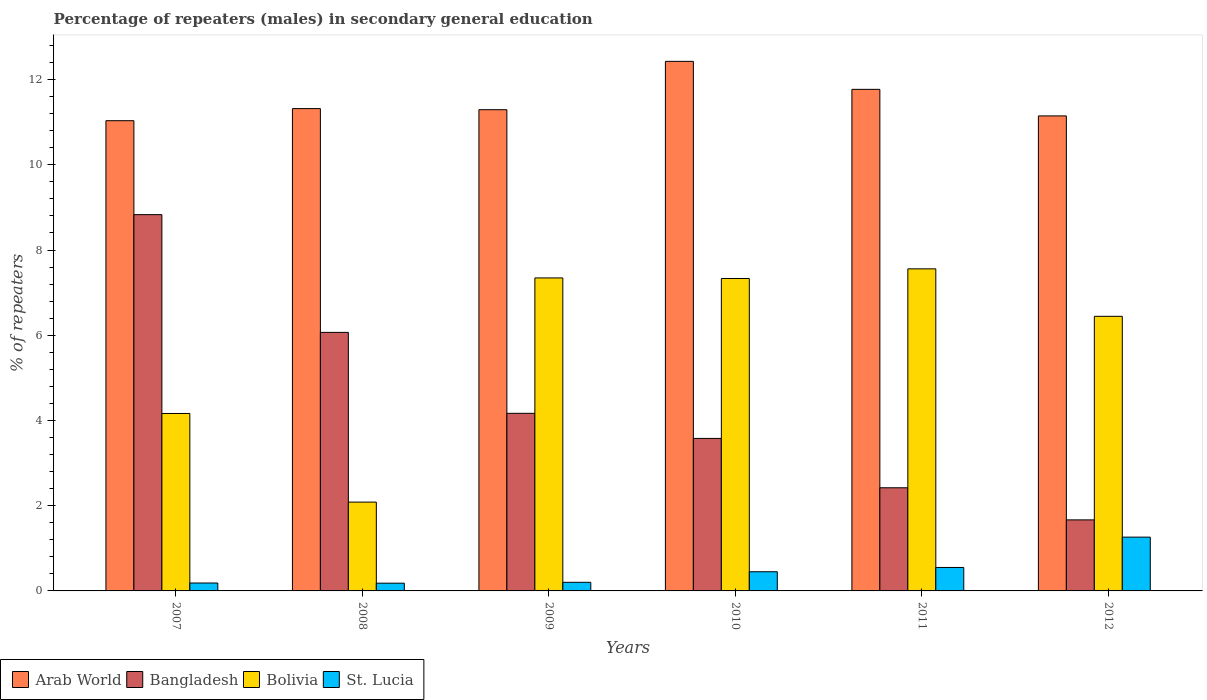How many different coloured bars are there?
Give a very brief answer. 4. How many groups of bars are there?
Your response must be concise. 6. Are the number of bars per tick equal to the number of legend labels?
Make the answer very short. Yes. Are the number of bars on each tick of the X-axis equal?
Offer a very short reply. Yes. What is the label of the 3rd group of bars from the left?
Make the answer very short. 2009. What is the percentage of male repeaters in St. Lucia in 2008?
Provide a succinct answer. 0.18. Across all years, what is the maximum percentage of male repeaters in Arab World?
Your answer should be very brief. 12.43. Across all years, what is the minimum percentage of male repeaters in Arab World?
Your response must be concise. 11.03. In which year was the percentage of male repeaters in St. Lucia maximum?
Offer a terse response. 2012. What is the total percentage of male repeaters in Arab World in the graph?
Your answer should be compact. 68.99. What is the difference between the percentage of male repeaters in Arab World in 2007 and that in 2008?
Provide a short and direct response. -0.28. What is the difference between the percentage of male repeaters in Bangladesh in 2008 and the percentage of male repeaters in Bolivia in 2012?
Offer a terse response. -0.38. What is the average percentage of male repeaters in St. Lucia per year?
Your answer should be very brief. 0.47. In the year 2008, what is the difference between the percentage of male repeaters in St. Lucia and percentage of male repeaters in Bangladesh?
Give a very brief answer. -5.89. In how many years, is the percentage of male repeaters in Arab World greater than 4.4 %?
Your response must be concise. 6. What is the ratio of the percentage of male repeaters in Arab World in 2008 to that in 2012?
Your answer should be very brief. 1.02. What is the difference between the highest and the second highest percentage of male repeaters in Bangladesh?
Give a very brief answer. 2.76. What is the difference between the highest and the lowest percentage of male repeaters in Arab World?
Offer a very short reply. 1.39. In how many years, is the percentage of male repeaters in Arab World greater than the average percentage of male repeaters in Arab World taken over all years?
Your response must be concise. 2. Are all the bars in the graph horizontal?
Your answer should be very brief. No. Are the values on the major ticks of Y-axis written in scientific E-notation?
Provide a succinct answer. No. Does the graph contain any zero values?
Offer a terse response. No. Does the graph contain grids?
Your answer should be compact. No. How are the legend labels stacked?
Offer a very short reply. Horizontal. What is the title of the graph?
Keep it short and to the point. Percentage of repeaters (males) in secondary general education. Does "European Union" appear as one of the legend labels in the graph?
Make the answer very short. No. What is the label or title of the Y-axis?
Your response must be concise. % of repeaters. What is the % of repeaters of Arab World in 2007?
Keep it short and to the point. 11.03. What is the % of repeaters in Bangladesh in 2007?
Keep it short and to the point. 8.83. What is the % of repeaters in Bolivia in 2007?
Keep it short and to the point. 4.16. What is the % of repeaters of St. Lucia in 2007?
Give a very brief answer. 0.19. What is the % of repeaters of Arab World in 2008?
Offer a very short reply. 11.32. What is the % of repeaters of Bangladesh in 2008?
Give a very brief answer. 6.07. What is the % of repeaters in Bolivia in 2008?
Provide a short and direct response. 2.08. What is the % of repeaters of St. Lucia in 2008?
Provide a succinct answer. 0.18. What is the % of repeaters in Arab World in 2009?
Make the answer very short. 11.29. What is the % of repeaters in Bangladesh in 2009?
Offer a very short reply. 4.17. What is the % of repeaters in Bolivia in 2009?
Provide a short and direct response. 7.34. What is the % of repeaters in St. Lucia in 2009?
Keep it short and to the point. 0.2. What is the % of repeaters of Arab World in 2010?
Your answer should be very brief. 12.43. What is the % of repeaters in Bangladesh in 2010?
Your answer should be compact. 3.58. What is the % of repeaters of Bolivia in 2010?
Your answer should be very brief. 7.33. What is the % of repeaters of St. Lucia in 2010?
Give a very brief answer. 0.45. What is the % of repeaters in Arab World in 2011?
Make the answer very short. 11.77. What is the % of repeaters of Bangladesh in 2011?
Your answer should be compact. 2.42. What is the % of repeaters of Bolivia in 2011?
Provide a succinct answer. 7.56. What is the % of repeaters in St. Lucia in 2011?
Your response must be concise. 0.55. What is the % of repeaters of Arab World in 2012?
Ensure brevity in your answer.  11.15. What is the % of repeaters in Bangladesh in 2012?
Keep it short and to the point. 1.67. What is the % of repeaters in Bolivia in 2012?
Your answer should be compact. 6.44. What is the % of repeaters of St. Lucia in 2012?
Your answer should be compact. 1.26. Across all years, what is the maximum % of repeaters of Arab World?
Offer a terse response. 12.43. Across all years, what is the maximum % of repeaters of Bangladesh?
Provide a short and direct response. 8.83. Across all years, what is the maximum % of repeaters of Bolivia?
Offer a terse response. 7.56. Across all years, what is the maximum % of repeaters in St. Lucia?
Offer a terse response. 1.26. Across all years, what is the minimum % of repeaters of Arab World?
Your response must be concise. 11.03. Across all years, what is the minimum % of repeaters in Bangladesh?
Your answer should be compact. 1.67. Across all years, what is the minimum % of repeaters in Bolivia?
Provide a short and direct response. 2.08. Across all years, what is the minimum % of repeaters in St. Lucia?
Provide a succinct answer. 0.18. What is the total % of repeaters in Arab World in the graph?
Provide a succinct answer. 68.99. What is the total % of repeaters of Bangladesh in the graph?
Provide a succinct answer. 26.73. What is the total % of repeaters in Bolivia in the graph?
Your response must be concise. 34.93. What is the total % of repeaters of St. Lucia in the graph?
Keep it short and to the point. 2.83. What is the difference between the % of repeaters of Arab World in 2007 and that in 2008?
Provide a short and direct response. -0.28. What is the difference between the % of repeaters of Bangladesh in 2007 and that in 2008?
Your response must be concise. 2.76. What is the difference between the % of repeaters of Bolivia in 2007 and that in 2008?
Offer a very short reply. 2.08. What is the difference between the % of repeaters of St. Lucia in 2007 and that in 2008?
Your answer should be very brief. 0. What is the difference between the % of repeaters in Arab World in 2007 and that in 2009?
Offer a very short reply. -0.26. What is the difference between the % of repeaters in Bangladesh in 2007 and that in 2009?
Provide a short and direct response. 4.66. What is the difference between the % of repeaters in Bolivia in 2007 and that in 2009?
Keep it short and to the point. -3.18. What is the difference between the % of repeaters in St. Lucia in 2007 and that in 2009?
Offer a very short reply. -0.02. What is the difference between the % of repeaters in Arab World in 2007 and that in 2010?
Your answer should be very brief. -1.39. What is the difference between the % of repeaters of Bangladesh in 2007 and that in 2010?
Provide a short and direct response. 5.25. What is the difference between the % of repeaters in Bolivia in 2007 and that in 2010?
Offer a very short reply. -3.17. What is the difference between the % of repeaters of St. Lucia in 2007 and that in 2010?
Give a very brief answer. -0.26. What is the difference between the % of repeaters in Arab World in 2007 and that in 2011?
Offer a very short reply. -0.74. What is the difference between the % of repeaters of Bangladesh in 2007 and that in 2011?
Provide a short and direct response. 6.41. What is the difference between the % of repeaters in Bolivia in 2007 and that in 2011?
Your response must be concise. -3.39. What is the difference between the % of repeaters in St. Lucia in 2007 and that in 2011?
Provide a succinct answer. -0.36. What is the difference between the % of repeaters in Arab World in 2007 and that in 2012?
Provide a short and direct response. -0.11. What is the difference between the % of repeaters of Bangladesh in 2007 and that in 2012?
Provide a succinct answer. 7.16. What is the difference between the % of repeaters in Bolivia in 2007 and that in 2012?
Provide a short and direct response. -2.28. What is the difference between the % of repeaters in St. Lucia in 2007 and that in 2012?
Your answer should be very brief. -1.08. What is the difference between the % of repeaters in Arab World in 2008 and that in 2009?
Provide a short and direct response. 0.03. What is the difference between the % of repeaters of Bangladesh in 2008 and that in 2009?
Keep it short and to the point. 1.9. What is the difference between the % of repeaters of Bolivia in 2008 and that in 2009?
Make the answer very short. -5.26. What is the difference between the % of repeaters of St. Lucia in 2008 and that in 2009?
Give a very brief answer. -0.02. What is the difference between the % of repeaters of Arab World in 2008 and that in 2010?
Provide a short and direct response. -1.11. What is the difference between the % of repeaters of Bangladesh in 2008 and that in 2010?
Make the answer very short. 2.49. What is the difference between the % of repeaters of Bolivia in 2008 and that in 2010?
Give a very brief answer. -5.25. What is the difference between the % of repeaters of St. Lucia in 2008 and that in 2010?
Provide a succinct answer. -0.27. What is the difference between the % of repeaters of Arab World in 2008 and that in 2011?
Your answer should be compact. -0.45. What is the difference between the % of repeaters in Bangladesh in 2008 and that in 2011?
Make the answer very short. 3.65. What is the difference between the % of repeaters of Bolivia in 2008 and that in 2011?
Make the answer very short. -5.47. What is the difference between the % of repeaters in St. Lucia in 2008 and that in 2011?
Provide a short and direct response. -0.37. What is the difference between the % of repeaters of Arab World in 2008 and that in 2012?
Provide a succinct answer. 0.17. What is the difference between the % of repeaters of Bolivia in 2008 and that in 2012?
Provide a succinct answer. -4.36. What is the difference between the % of repeaters in St. Lucia in 2008 and that in 2012?
Offer a very short reply. -1.08. What is the difference between the % of repeaters in Arab World in 2009 and that in 2010?
Ensure brevity in your answer.  -1.13. What is the difference between the % of repeaters of Bangladesh in 2009 and that in 2010?
Offer a terse response. 0.59. What is the difference between the % of repeaters of Bolivia in 2009 and that in 2010?
Offer a very short reply. 0.01. What is the difference between the % of repeaters of St. Lucia in 2009 and that in 2010?
Make the answer very short. -0.25. What is the difference between the % of repeaters in Arab World in 2009 and that in 2011?
Provide a short and direct response. -0.48. What is the difference between the % of repeaters of Bangladesh in 2009 and that in 2011?
Make the answer very short. 1.75. What is the difference between the % of repeaters in Bolivia in 2009 and that in 2011?
Make the answer very short. -0.21. What is the difference between the % of repeaters of St. Lucia in 2009 and that in 2011?
Your answer should be very brief. -0.35. What is the difference between the % of repeaters in Arab World in 2009 and that in 2012?
Ensure brevity in your answer.  0.15. What is the difference between the % of repeaters of Bangladesh in 2009 and that in 2012?
Provide a succinct answer. 2.5. What is the difference between the % of repeaters in Bolivia in 2009 and that in 2012?
Keep it short and to the point. 0.9. What is the difference between the % of repeaters in St. Lucia in 2009 and that in 2012?
Offer a terse response. -1.06. What is the difference between the % of repeaters in Arab World in 2010 and that in 2011?
Your answer should be very brief. 0.66. What is the difference between the % of repeaters of Bangladesh in 2010 and that in 2011?
Provide a succinct answer. 1.16. What is the difference between the % of repeaters of Bolivia in 2010 and that in 2011?
Keep it short and to the point. -0.23. What is the difference between the % of repeaters of St. Lucia in 2010 and that in 2011?
Provide a succinct answer. -0.1. What is the difference between the % of repeaters in Arab World in 2010 and that in 2012?
Your response must be concise. 1.28. What is the difference between the % of repeaters of Bangladesh in 2010 and that in 2012?
Provide a succinct answer. 1.91. What is the difference between the % of repeaters in Bolivia in 2010 and that in 2012?
Ensure brevity in your answer.  0.89. What is the difference between the % of repeaters in St. Lucia in 2010 and that in 2012?
Your answer should be very brief. -0.81. What is the difference between the % of repeaters of Arab World in 2011 and that in 2012?
Keep it short and to the point. 0.62. What is the difference between the % of repeaters of Bangladesh in 2011 and that in 2012?
Keep it short and to the point. 0.75. What is the difference between the % of repeaters of Bolivia in 2011 and that in 2012?
Give a very brief answer. 1.11. What is the difference between the % of repeaters in St. Lucia in 2011 and that in 2012?
Provide a succinct answer. -0.71. What is the difference between the % of repeaters in Arab World in 2007 and the % of repeaters in Bangladesh in 2008?
Your answer should be compact. 4.97. What is the difference between the % of repeaters in Arab World in 2007 and the % of repeaters in Bolivia in 2008?
Keep it short and to the point. 8.95. What is the difference between the % of repeaters in Arab World in 2007 and the % of repeaters in St. Lucia in 2008?
Offer a very short reply. 10.85. What is the difference between the % of repeaters of Bangladesh in 2007 and the % of repeaters of Bolivia in 2008?
Make the answer very short. 6.75. What is the difference between the % of repeaters in Bangladesh in 2007 and the % of repeaters in St. Lucia in 2008?
Provide a short and direct response. 8.65. What is the difference between the % of repeaters of Bolivia in 2007 and the % of repeaters of St. Lucia in 2008?
Give a very brief answer. 3.98. What is the difference between the % of repeaters in Arab World in 2007 and the % of repeaters in Bangladesh in 2009?
Provide a short and direct response. 6.87. What is the difference between the % of repeaters in Arab World in 2007 and the % of repeaters in Bolivia in 2009?
Offer a terse response. 3.69. What is the difference between the % of repeaters in Arab World in 2007 and the % of repeaters in St. Lucia in 2009?
Your answer should be very brief. 10.83. What is the difference between the % of repeaters in Bangladesh in 2007 and the % of repeaters in Bolivia in 2009?
Your answer should be very brief. 1.49. What is the difference between the % of repeaters of Bangladesh in 2007 and the % of repeaters of St. Lucia in 2009?
Offer a very short reply. 8.63. What is the difference between the % of repeaters of Bolivia in 2007 and the % of repeaters of St. Lucia in 2009?
Offer a terse response. 3.96. What is the difference between the % of repeaters of Arab World in 2007 and the % of repeaters of Bangladesh in 2010?
Ensure brevity in your answer.  7.46. What is the difference between the % of repeaters in Arab World in 2007 and the % of repeaters in Bolivia in 2010?
Provide a succinct answer. 3.7. What is the difference between the % of repeaters of Arab World in 2007 and the % of repeaters of St. Lucia in 2010?
Keep it short and to the point. 10.58. What is the difference between the % of repeaters of Bangladesh in 2007 and the % of repeaters of Bolivia in 2010?
Provide a succinct answer. 1.5. What is the difference between the % of repeaters of Bangladesh in 2007 and the % of repeaters of St. Lucia in 2010?
Make the answer very short. 8.38. What is the difference between the % of repeaters of Bolivia in 2007 and the % of repeaters of St. Lucia in 2010?
Offer a terse response. 3.71. What is the difference between the % of repeaters of Arab World in 2007 and the % of repeaters of Bangladesh in 2011?
Make the answer very short. 8.61. What is the difference between the % of repeaters in Arab World in 2007 and the % of repeaters in Bolivia in 2011?
Your answer should be very brief. 3.48. What is the difference between the % of repeaters of Arab World in 2007 and the % of repeaters of St. Lucia in 2011?
Provide a short and direct response. 10.48. What is the difference between the % of repeaters of Bangladesh in 2007 and the % of repeaters of Bolivia in 2011?
Offer a very short reply. 1.27. What is the difference between the % of repeaters in Bangladesh in 2007 and the % of repeaters in St. Lucia in 2011?
Offer a terse response. 8.28. What is the difference between the % of repeaters of Bolivia in 2007 and the % of repeaters of St. Lucia in 2011?
Your answer should be compact. 3.61. What is the difference between the % of repeaters of Arab World in 2007 and the % of repeaters of Bangladesh in 2012?
Your response must be concise. 9.37. What is the difference between the % of repeaters of Arab World in 2007 and the % of repeaters of Bolivia in 2012?
Your answer should be very brief. 4.59. What is the difference between the % of repeaters of Arab World in 2007 and the % of repeaters of St. Lucia in 2012?
Provide a succinct answer. 9.77. What is the difference between the % of repeaters in Bangladesh in 2007 and the % of repeaters in Bolivia in 2012?
Offer a terse response. 2.39. What is the difference between the % of repeaters in Bangladesh in 2007 and the % of repeaters in St. Lucia in 2012?
Your answer should be compact. 7.57. What is the difference between the % of repeaters of Bolivia in 2007 and the % of repeaters of St. Lucia in 2012?
Offer a terse response. 2.9. What is the difference between the % of repeaters in Arab World in 2008 and the % of repeaters in Bangladesh in 2009?
Provide a short and direct response. 7.15. What is the difference between the % of repeaters of Arab World in 2008 and the % of repeaters of Bolivia in 2009?
Your answer should be compact. 3.97. What is the difference between the % of repeaters in Arab World in 2008 and the % of repeaters in St. Lucia in 2009?
Make the answer very short. 11.12. What is the difference between the % of repeaters in Bangladesh in 2008 and the % of repeaters in Bolivia in 2009?
Make the answer very short. -1.28. What is the difference between the % of repeaters of Bangladesh in 2008 and the % of repeaters of St. Lucia in 2009?
Ensure brevity in your answer.  5.86. What is the difference between the % of repeaters in Bolivia in 2008 and the % of repeaters in St. Lucia in 2009?
Your answer should be very brief. 1.88. What is the difference between the % of repeaters of Arab World in 2008 and the % of repeaters of Bangladesh in 2010?
Keep it short and to the point. 7.74. What is the difference between the % of repeaters of Arab World in 2008 and the % of repeaters of Bolivia in 2010?
Ensure brevity in your answer.  3.99. What is the difference between the % of repeaters in Arab World in 2008 and the % of repeaters in St. Lucia in 2010?
Give a very brief answer. 10.87. What is the difference between the % of repeaters in Bangladesh in 2008 and the % of repeaters in Bolivia in 2010?
Your answer should be compact. -1.26. What is the difference between the % of repeaters in Bangladesh in 2008 and the % of repeaters in St. Lucia in 2010?
Your answer should be very brief. 5.62. What is the difference between the % of repeaters of Bolivia in 2008 and the % of repeaters of St. Lucia in 2010?
Your response must be concise. 1.63. What is the difference between the % of repeaters in Arab World in 2008 and the % of repeaters in Bangladesh in 2011?
Ensure brevity in your answer.  8.9. What is the difference between the % of repeaters of Arab World in 2008 and the % of repeaters of Bolivia in 2011?
Make the answer very short. 3.76. What is the difference between the % of repeaters of Arab World in 2008 and the % of repeaters of St. Lucia in 2011?
Provide a succinct answer. 10.77. What is the difference between the % of repeaters of Bangladesh in 2008 and the % of repeaters of Bolivia in 2011?
Ensure brevity in your answer.  -1.49. What is the difference between the % of repeaters in Bangladesh in 2008 and the % of repeaters in St. Lucia in 2011?
Ensure brevity in your answer.  5.52. What is the difference between the % of repeaters in Bolivia in 2008 and the % of repeaters in St. Lucia in 2011?
Your answer should be very brief. 1.53. What is the difference between the % of repeaters in Arab World in 2008 and the % of repeaters in Bangladesh in 2012?
Ensure brevity in your answer.  9.65. What is the difference between the % of repeaters in Arab World in 2008 and the % of repeaters in Bolivia in 2012?
Provide a short and direct response. 4.87. What is the difference between the % of repeaters of Arab World in 2008 and the % of repeaters of St. Lucia in 2012?
Give a very brief answer. 10.06. What is the difference between the % of repeaters in Bangladesh in 2008 and the % of repeaters in Bolivia in 2012?
Your response must be concise. -0.38. What is the difference between the % of repeaters in Bangladesh in 2008 and the % of repeaters in St. Lucia in 2012?
Ensure brevity in your answer.  4.8. What is the difference between the % of repeaters in Bolivia in 2008 and the % of repeaters in St. Lucia in 2012?
Your answer should be compact. 0.82. What is the difference between the % of repeaters of Arab World in 2009 and the % of repeaters of Bangladesh in 2010?
Offer a terse response. 7.71. What is the difference between the % of repeaters in Arab World in 2009 and the % of repeaters in Bolivia in 2010?
Keep it short and to the point. 3.96. What is the difference between the % of repeaters of Arab World in 2009 and the % of repeaters of St. Lucia in 2010?
Your response must be concise. 10.84. What is the difference between the % of repeaters in Bangladesh in 2009 and the % of repeaters in Bolivia in 2010?
Provide a succinct answer. -3.16. What is the difference between the % of repeaters in Bangladesh in 2009 and the % of repeaters in St. Lucia in 2010?
Your answer should be very brief. 3.72. What is the difference between the % of repeaters of Bolivia in 2009 and the % of repeaters of St. Lucia in 2010?
Your answer should be very brief. 6.89. What is the difference between the % of repeaters in Arab World in 2009 and the % of repeaters in Bangladesh in 2011?
Offer a very short reply. 8.87. What is the difference between the % of repeaters of Arab World in 2009 and the % of repeaters of Bolivia in 2011?
Provide a succinct answer. 3.73. What is the difference between the % of repeaters of Arab World in 2009 and the % of repeaters of St. Lucia in 2011?
Your answer should be compact. 10.74. What is the difference between the % of repeaters in Bangladesh in 2009 and the % of repeaters in Bolivia in 2011?
Make the answer very short. -3.39. What is the difference between the % of repeaters in Bangladesh in 2009 and the % of repeaters in St. Lucia in 2011?
Provide a succinct answer. 3.62. What is the difference between the % of repeaters of Bolivia in 2009 and the % of repeaters of St. Lucia in 2011?
Offer a very short reply. 6.79. What is the difference between the % of repeaters in Arab World in 2009 and the % of repeaters in Bangladesh in 2012?
Your answer should be very brief. 9.63. What is the difference between the % of repeaters in Arab World in 2009 and the % of repeaters in Bolivia in 2012?
Ensure brevity in your answer.  4.85. What is the difference between the % of repeaters in Arab World in 2009 and the % of repeaters in St. Lucia in 2012?
Provide a succinct answer. 10.03. What is the difference between the % of repeaters of Bangladesh in 2009 and the % of repeaters of Bolivia in 2012?
Make the answer very short. -2.28. What is the difference between the % of repeaters in Bangladesh in 2009 and the % of repeaters in St. Lucia in 2012?
Offer a very short reply. 2.91. What is the difference between the % of repeaters in Bolivia in 2009 and the % of repeaters in St. Lucia in 2012?
Ensure brevity in your answer.  6.08. What is the difference between the % of repeaters of Arab World in 2010 and the % of repeaters of Bangladesh in 2011?
Provide a succinct answer. 10.01. What is the difference between the % of repeaters of Arab World in 2010 and the % of repeaters of Bolivia in 2011?
Your response must be concise. 4.87. What is the difference between the % of repeaters of Arab World in 2010 and the % of repeaters of St. Lucia in 2011?
Keep it short and to the point. 11.88. What is the difference between the % of repeaters in Bangladesh in 2010 and the % of repeaters in Bolivia in 2011?
Offer a very short reply. -3.98. What is the difference between the % of repeaters in Bangladesh in 2010 and the % of repeaters in St. Lucia in 2011?
Your answer should be very brief. 3.03. What is the difference between the % of repeaters in Bolivia in 2010 and the % of repeaters in St. Lucia in 2011?
Offer a very short reply. 6.78. What is the difference between the % of repeaters in Arab World in 2010 and the % of repeaters in Bangladesh in 2012?
Your answer should be very brief. 10.76. What is the difference between the % of repeaters in Arab World in 2010 and the % of repeaters in Bolivia in 2012?
Give a very brief answer. 5.98. What is the difference between the % of repeaters of Arab World in 2010 and the % of repeaters of St. Lucia in 2012?
Offer a terse response. 11.17. What is the difference between the % of repeaters in Bangladesh in 2010 and the % of repeaters in Bolivia in 2012?
Ensure brevity in your answer.  -2.87. What is the difference between the % of repeaters in Bangladesh in 2010 and the % of repeaters in St. Lucia in 2012?
Offer a very short reply. 2.32. What is the difference between the % of repeaters in Bolivia in 2010 and the % of repeaters in St. Lucia in 2012?
Provide a short and direct response. 6.07. What is the difference between the % of repeaters in Arab World in 2011 and the % of repeaters in Bangladesh in 2012?
Keep it short and to the point. 10.1. What is the difference between the % of repeaters in Arab World in 2011 and the % of repeaters in Bolivia in 2012?
Provide a succinct answer. 5.33. What is the difference between the % of repeaters of Arab World in 2011 and the % of repeaters of St. Lucia in 2012?
Your answer should be very brief. 10.51. What is the difference between the % of repeaters of Bangladesh in 2011 and the % of repeaters of Bolivia in 2012?
Your answer should be very brief. -4.02. What is the difference between the % of repeaters in Bangladesh in 2011 and the % of repeaters in St. Lucia in 2012?
Provide a short and direct response. 1.16. What is the difference between the % of repeaters in Bolivia in 2011 and the % of repeaters in St. Lucia in 2012?
Provide a succinct answer. 6.3. What is the average % of repeaters in Arab World per year?
Offer a very short reply. 11.5. What is the average % of repeaters in Bangladesh per year?
Keep it short and to the point. 4.46. What is the average % of repeaters in Bolivia per year?
Keep it short and to the point. 5.82. What is the average % of repeaters of St. Lucia per year?
Offer a very short reply. 0.47. In the year 2007, what is the difference between the % of repeaters of Arab World and % of repeaters of Bangladesh?
Give a very brief answer. 2.2. In the year 2007, what is the difference between the % of repeaters in Arab World and % of repeaters in Bolivia?
Offer a terse response. 6.87. In the year 2007, what is the difference between the % of repeaters in Arab World and % of repeaters in St. Lucia?
Your answer should be compact. 10.85. In the year 2007, what is the difference between the % of repeaters of Bangladesh and % of repeaters of Bolivia?
Provide a short and direct response. 4.67. In the year 2007, what is the difference between the % of repeaters in Bangladesh and % of repeaters in St. Lucia?
Offer a very short reply. 8.64. In the year 2007, what is the difference between the % of repeaters in Bolivia and % of repeaters in St. Lucia?
Ensure brevity in your answer.  3.98. In the year 2008, what is the difference between the % of repeaters in Arab World and % of repeaters in Bangladesh?
Offer a very short reply. 5.25. In the year 2008, what is the difference between the % of repeaters in Arab World and % of repeaters in Bolivia?
Your answer should be compact. 9.23. In the year 2008, what is the difference between the % of repeaters in Arab World and % of repeaters in St. Lucia?
Your response must be concise. 11.14. In the year 2008, what is the difference between the % of repeaters of Bangladesh and % of repeaters of Bolivia?
Offer a terse response. 3.98. In the year 2008, what is the difference between the % of repeaters in Bangladesh and % of repeaters in St. Lucia?
Make the answer very short. 5.89. In the year 2008, what is the difference between the % of repeaters of Bolivia and % of repeaters of St. Lucia?
Provide a succinct answer. 1.9. In the year 2009, what is the difference between the % of repeaters of Arab World and % of repeaters of Bangladesh?
Give a very brief answer. 7.12. In the year 2009, what is the difference between the % of repeaters of Arab World and % of repeaters of Bolivia?
Make the answer very short. 3.95. In the year 2009, what is the difference between the % of repeaters of Arab World and % of repeaters of St. Lucia?
Your answer should be compact. 11.09. In the year 2009, what is the difference between the % of repeaters in Bangladesh and % of repeaters in Bolivia?
Your answer should be very brief. -3.18. In the year 2009, what is the difference between the % of repeaters in Bangladesh and % of repeaters in St. Lucia?
Ensure brevity in your answer.  3.97. In the year 2009, what is the difference between the % of repeaters of Bolivia and % of repeaters of St. Lucia?
Provide a succinct answer. 7.14. In the year 2010, what is the difference between the % of repeaters of Arab World and % of repeaters of Bangladesh?
Your response must be concise. 8.85. In the year 2010, what is the difference between the % of repeaters of Arab World and % of repeaters of Bolivia?
Offer a terse response. 5.1. In the year 2010, what is the difference between the % of repeaters of Arab World and % of repeaters of St. Lucia?
Offer a terse response. 11.98. In the year 2010, what is the difference between the % of repeaters in Bangladesh and % of repeaters in Bolivia?
Make the answer very short. -3.75. In the year 2010, what is the difference between the % of repeaters of Bangladesh and % of repeaters of St. Lucia?
Keep it short and to the point. 3.13. In the year 2010, what is the difference between the % of repeaters of Bolivia and % of repeaters of St. Lucia?
Your response must be concise. 6.88. In the year 2011, what is the difference between the % of repeaters in Arab World and % of repeaters in Bangladesh?
Your response must be concise. 9.35. In the year 2011, what is the difference between the % of repeaters of Arab World and % of repeaters of Bolivia?
Make the answer very short. 4.21. In the year 2011, what is the difference between the % of repeaters in Arab World and % of repeaters in St. Lucia?
Provide a short and direct response. 11.22. In the year 2011, what is the difference between the % of repeaters of Bangladesh and % of repeaters of Bolivia?
Give a very brief answer. -5.14. In the year 2011, what is the difference between the % of repeaters of Bangladesh and % of repeaters of St. Lucia?
Give a very brief answer. 1.87. In the year 2011, what is the difference between the % of repeaters in Bolivia and % of repeaters in St. Lucia?
Offer a terse response. 7.01. In the year 2012, what is the difference between the % of repeaters in Arab World and % of repeaters in Bangladesh?
Ensure brevity in your answer.  9.48. In the year 2012, what is the difference between the % of repeaters of Arab World and % of repeaters of Bolivia?
Your response must be concise. 4.7. In the year 2012, what is the difference between the % of repeaters of Arab World and % of repeaters of St. Lucia?
Offer a very short reply. 9.88. In the year 2012, what is the difference between the % of repeaters of Bangladesh and % of repeaters of Bolivia?
Offer a very short reply. -4.78. In the year 2012, what is the difference between the % of repeaters of Bangladesh and % of repeaters of St. Lucia?
Give a very brief answer. 0.4. In the year 2012, what is the difference between the % of repeaters of Bolivia and % of repeaters of St. Lucia?
Provide a succinct answer. 5.18. What is the ratio of the % of repeaters in Arab World in 2007 to that in 2008?
Provide a short and direct response. 0.97. What is the ratio of the % of repeaters in Bangladesh in 2007 to that in 2008?
Your response must be concise. 1.46. What is the ratio of the % of repeaters in Bolivia in 2007 to that in 2008?
Ensure brevity in your answer.  2. What is the ratio of the % of repeaters in St. Lucia in 2007 to that in 2008?
Provide a succinct answer. 1.02. What is the ratio of the % of repeaters in Arab World in 2007 to that in 2009?
Provide a succinct answer. 0.98. What is the ratio of the % of repeaters of Bangladesh in 2007 to that in 2009?
Your response must be concise. 2.12. What is the ratio of the % of repeaters of Bolivia in 2007 to that in 2009?
Your answer should be compact. 0.57. What is the ratio of the % of repeaters in St. Lucia in 2007 to that in 2009?
Your answer should be compact. 0.92. What is the ratio of the % of repeaters in Arab World in 2007 to that in 2010?
Your answer should be very brief. 0.89. What is the ratio of the % of repeaters of Bangladesh in 2007 to that in 2010?
Your response must be concise. 2.47. What is the ratio of the % of repeaters of Bolivia in 2007 to that in 2010?
Your answer should be very brief. 0.57. What is the ratio of the % of repeaters in St. Lucia in 2007 to that in 2010?
Your response must be concise. 0.41. What is the ratio of the % of repeaters of Arab World in 2007 to that in 2011?
Make the answer very short. 0.94. What is the ratio of the % of repeaters of Bangladesh in 2007 to that in 2011?
Your answer should be compact. 3.65. What is the ratio of the % of repeaters in Bolivia in 2007 to that in 2011?
Keep it short and to the point. 0.55. What is the ratio of the % of repeaters in St. Lucia in 2007 to that in 2011?
Offer a terse response. 0.34. What is the ratio of the % of repeaters of Bangladesh in 2007 to that in 2012?
Give a very brief answer. 5.3. What is the ratio of the % of repeaters of Bolivia in 2007 to that in 2012?
Your response must be concise. 0.65. What is the ratio of the % of repeaters in St. Lucia in 2007 to that in 2012?
Give a very brief answer. 0.15. What is the ratio of the % of repeaters in Arab World in 2008 to that in 2009?
Keep it short and to the point. 1. What is the ratio of the % of repeaters of Bangladesh in 2008 to that in 2009?
Your answer should be very brief. 1.46. What is the ratio of the % of repeaters of Bolivia in 2008 to that in 2009?
Keep it short and to the point. 0.28. What is the ratio of the % of repeaters of St. Lucia in 2008 to that in 2009?
Make the answer very short. 0.9. What is the ratio of the % of repeaters in Arab World in 2008 to that in 2010?
Keep it short and to the point. 0.91. What is the ratio of the % of repeaters in Bangladesh in 2008 to that in 2010?
Provide a succinct answer. 1.7. What is the ratio of the % of repeaters in Bolivia in 2008 to that in 2010?
Provide a succinct answer. 0.28. What is the ratio of the % of repeaters in St. Lucia in 2008 to that in 2010?
Provide a succinct answer. 0.4. What is the ratio of the % of repeaters of Arab World in 2008 to that in 2011?
Give a very brief answer. 0.96. What is the ratio of the % of repeaters in Bangladesh in 2008 to that in 2011?
Provide a succinct answer. 2.51. What is the ratio of the % of repeaters of Bolivia in 2008 to that in 2011?
Give a very brief answer. 0.28. What is the ratio of the % of repeaters of St. Lucia in 2008 to that in 2011?
Offer a terse response. 0.33. What is the ratio of the % of repeaters of Arab World in 2008 to that in 2012?
Offer a very short reply. 1.02. What is the ratio of the % of repeaters in Bangladesh in 2008 to that in 2012?
Ensure brevity in your answer.  3.64. What is the ratio of the % of repeaters of Bolivia in 2008 to that in 2012?
Provide a short and direct response. 0.32. What is the ratio of the % of repeaters in St. Lucia in 2008 to that in 2012?
Give a very brief answer. 0.14. What is the ratio of the % of repeaters of Arab World in 2009 to that in 2010?
Give a very brief answer. 0.91. What is the ratio of the % of repeaters in Bangladesh in 2009 to that in 2010?
Provide a succinct answer. 1.16. What is the ratio of the % of repeaters in Bolivia in 2009 to that in 2010?
Your response must be concise. 1. What is the ratio of the % of repeaters in St. Lucia in 2009 to that in 2010?
Make the answer very short. 0.45. What is the ratio of the % of repeaters of Arab World in 2009 to that in 2011?
Make the answer very short. 0.96. What is the ratio of the % of repeaters in Bangladesh in 2009 to that in 2011?
Your answer should be compact. 1.72. What is the ratio of the % of repeaters of Bolivia in 2009 to that in 2011?
Your response must be concise. 0.97. What is the ratio of the % of repeaters in St. Lucia in 2009 to that in 2011?
Offer a very short reply. 0.37. What is the ratio of the % of repeaters of Arab World in 2009 to that in 2012?
Provide a short and direct response. 1.01. What is the ratio of the % of repeaters of Bangladesh in 2009 to that in 2012?
Your answer should be very brief. 2.5. What is the ratio of the % of repeaters in Bolivia in 2009 to that in 2012?
Your answer should be compact. 1.14. What is the ratio of the % of repeaters of St. Lucia in 2009 to that in 2012?
Offer a terse response. 0.16. What is the ratio of the % of repeaters of Arab World in 2010 to that in 2011?
Your answer should be very brief. 1.06. What is the ratio of the % of repeaters of Bangladesh in 2010 to that in 2011?
Give a very brief answer. 1.48. What is the ratio of the % of repeaters in St. Lucia in 2010 to that in 2011?
Offer a terse response. 0.82. What is the ratio of the % of repeaters of Arab World in 2010 to that in 2012?
Offer a terse response. 1.11. What is the ratio of the % of repeaters in Bangladesh in 2010 to that in 2012?
Make the answer very short. 2.15. What is the ratio of the % of repeaters of Bolivia in 2010 to that in 2012?
Give a very brief answer. 1.14. What is the ratio of the % of repeaters in St. Lucia in 2010 to that in 2012?
Your answer should be very brief. 0.36. What is the ratio of the % of repeaters of Arab World in 2011 to that in 2012?
Make the answer very short. 1.06. What is the ratio of the % of repeaters in Bangladesh in 2011 to that in 2012?
Provide a succinct answer. 1.45. What is the ratio of the % of repeaters in Bolivia in 2011 to that in 2012?
Offer a terse response. 1.17. What is the ratio of the % of repeaters in St. Lucia in 2011 to that in 2012?
Provide a succinct answer. 0.44. What is the difference between the highest and the second highest % of repeaters of Arab World?
Your answer should be compact. 0.66. What is the difference between the highest and the second highest % of repeaters of Bangladesh?
Keep it short and to the point. 2.76. What is the difference between the highest and the second highest % of repeaters of Bolivia?
Offer a terse response. 0.21. What is the difference between the highest and the second highest % of repeaters of St. Lucia?
Provide a succinct answer. 0.71. What is the difference between the highest and the lowest % of repeaters in Arab World?
Offer a terse response. 1.39. What is the difference between the highest and the lowest % of repeaters in Bangladesh?
Keep it short and to the point. 7.16. What is the difference between the highest and the lowest % of repeaters in Bolivia?
Offer a terse response. 5.47. What is the difference between the highest and the lowest % of repeaters in St. Lucia?
Give a very brief answer. 1.08. 